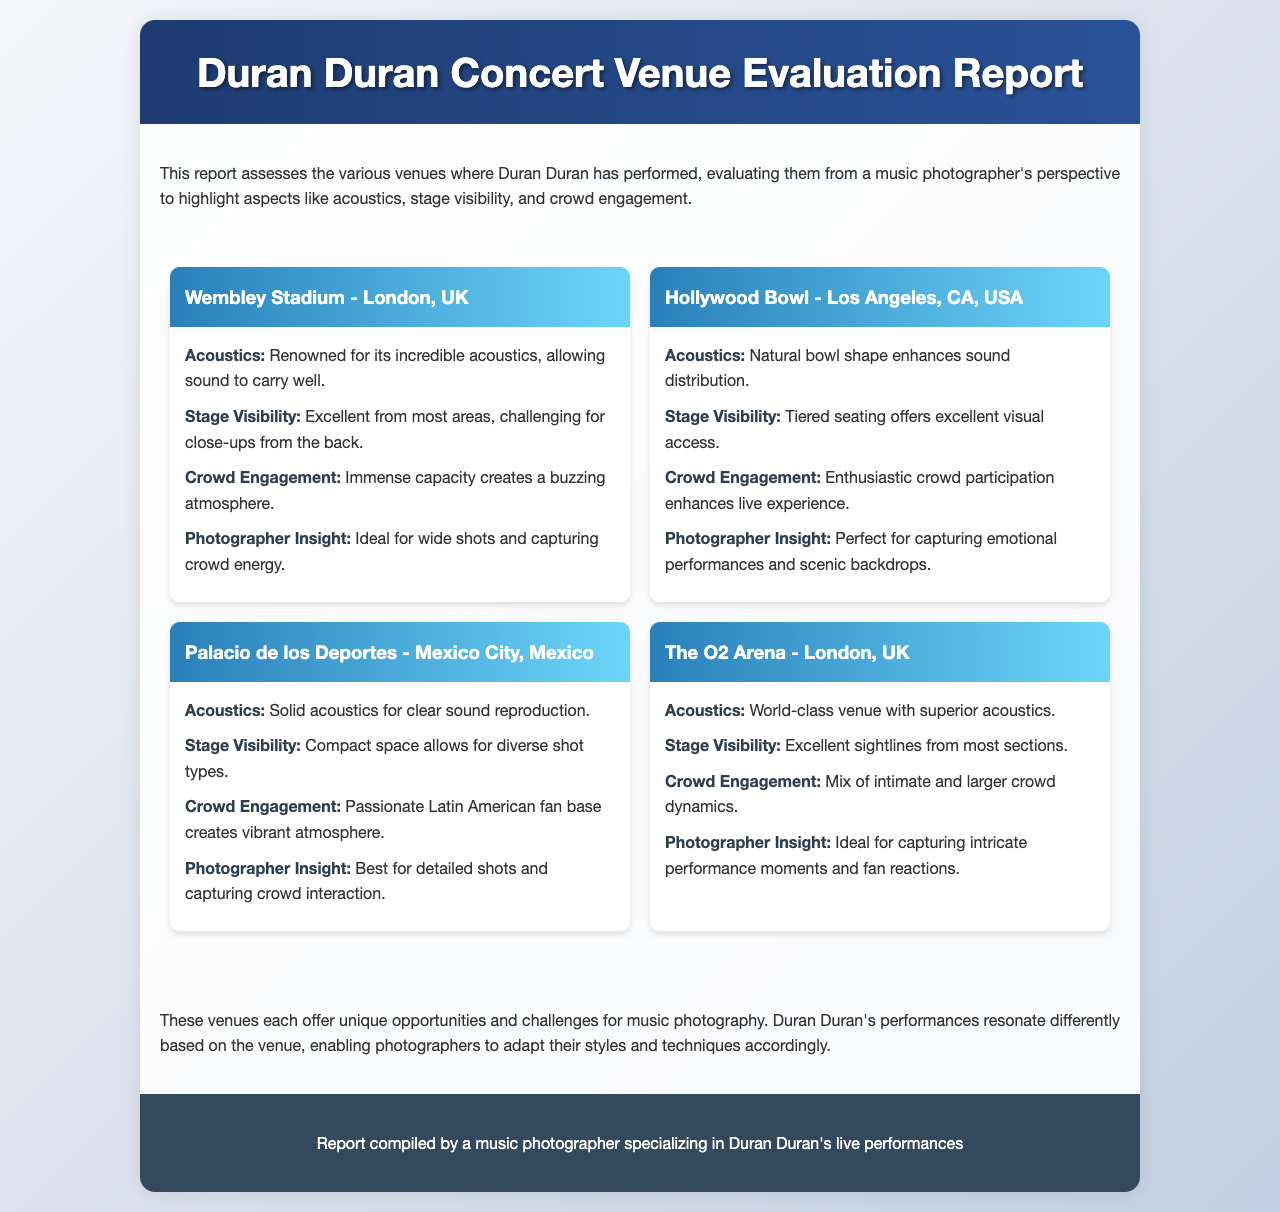What venue has the best acoustics? The document states that Wembley Stadium is renowned for its incredible acoustics, allowing sound to carry well.
Answer: Wembley Stadium Which venue is located in Los Angeles? The report mentions Hollywood Bowl as the venue located in Los Angeles, CA, USA.
Answer: Hollywood Bowl What is the crowd engagement like at Palacio de los Deportes? The report describes the crowd engagement as a passionate Latin American fan base creating a vibrant atmosphere.
Answer: Vibrant atmosphere How does The O2 Arena rate on stage visibility? The document indicates excellent sightlines from most sections for The O2 Arena.
Answer: Excellent What type of shots is best suited for Hollywood Bowl? The report suggests that the Hollywood Bowl is perfect for capturing emotional performances and scenic backdrops.
Answer: Emotional performances and scenic backdrops Which venue is highlighted for capturing intricate performance moments? The O2 Arena is identified as ideal for capturing intricate performance moments and fan reactions.
Answer: The O2 Arena What is the capacity characteristic of Wembley Stadium? The report notes that the immense capacity creates a buzzing atmosphere for crowd engagement.
Answer: Immense capacity Which venue offers tiered seating? The document states that Hollywood Bowl offers tiered seating, which provides excellent visual access.
Answer: Hollywood Bowl What does the report conclude about music photography at these venues? The conclusion highlights that each venue presents unique opportunities and challenges for music photography.
Answer: Unique opportunities and challenges 